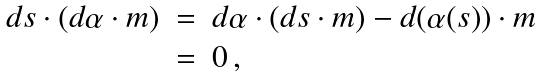Convert formula to latex. <formula><loc_0><loc_0><loc_500><loc_500>\begin{array} { r c l } d s \cdot ( d \alpha \cdot m ) & = & d \alpha \cdot ( d s \cdot m ) - d ( \alpha ( s ) ) \cdot m \\ & = & 0 \, , \end{array}</formula> 